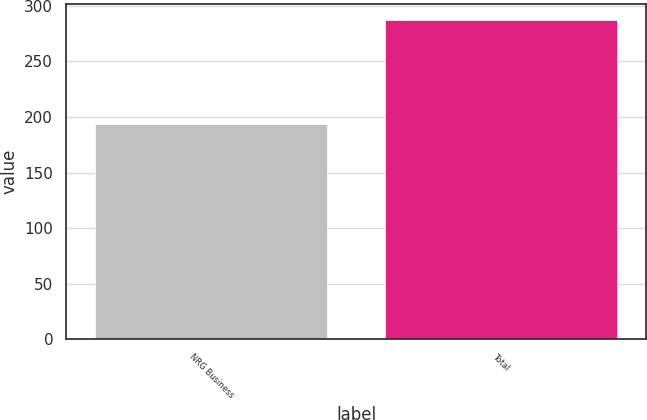Convert chart to OTSL. <chart><loc_0><loc_0><loc_500><loc_500><bar_chart><fcel>NRG Business<fcel>Total<nl><fcel>194<fcel>287<nl></chart> 